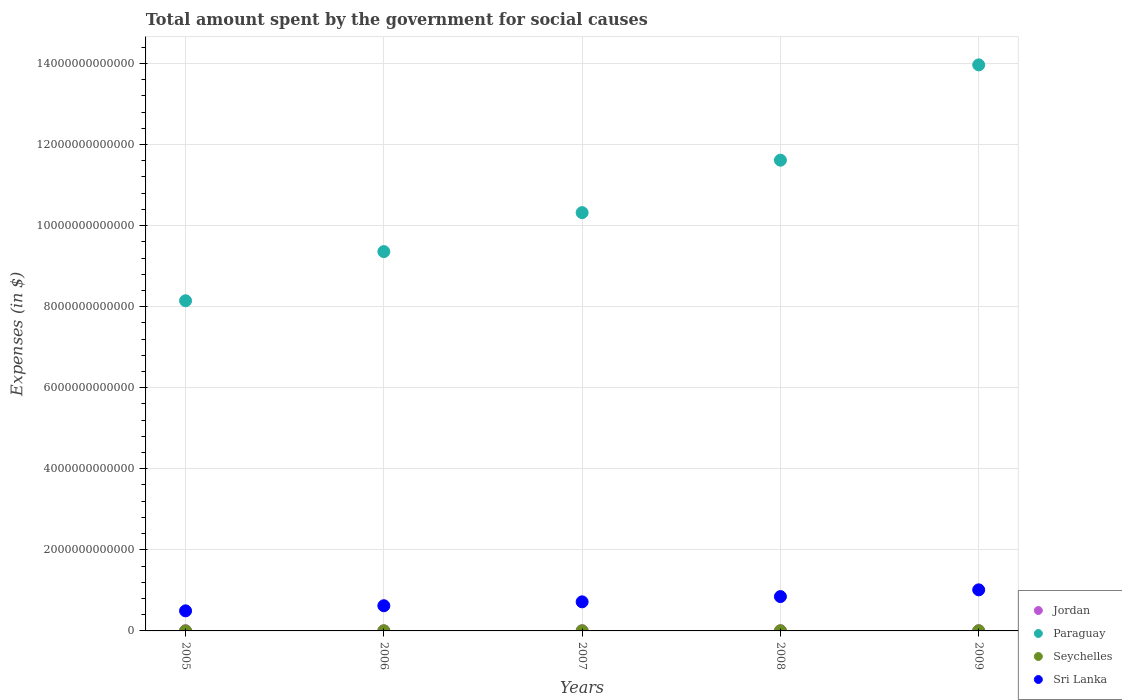Is the number of dotlines equal to the number of legend labels?
Provide a short and direct response. Yes. What is the amount spent for social causes by the government in Paraguay in 2006?
Offer a terse response. 9.36e+12. Across all years, what is the maximum amount spent for social causes by the government in Seychelles?
Your response must be concise. 3.40e+09. Across all years, what is the minimum amount spent for social causes by the government in Paraguay?
Make the answer very short. 8.15e+12. In which year was the amount spent for social causes by the government in Paraguay maximum?
Your response must be concise. 2009. In which year was the amount spent for social causes by the government in Jordan minimum?
Ensure brevity in your answer.  2005. What is the total amount spent for social causes by the government in Jordan in the graph?
Offer a very short reply. 2.08e+1. What is the difference between the amount spent for social causes by the government in Jordan in 2007 and that in 2008?
Offer a very short reply. -7.89e+08. What is the difference between the amount spent for social causes by the government in Seychelles in 2006 and the amount spent for social causes by the government in Sri Lanka in 2007?
Provide a short and direct response. -7.15e+11. What is the average amount spent for social causes by the government in Seychelles per year?
Make the answer very short. 2.52e+09. In the year 2006, what is the difference between the amount spent for social causes by the government in Paraguay and amount spent for social causes by the government in Sri Lanka?
Keep it short and to the point. 8.74e+12. What is the ratio of the amount spent for social causes by the government in Paraguay in 2006 to that in 2008?
Your answer should be compact. 0.81. Is the amount spent for social causes by the government in Jordan in 2006 less than that in 2009?
Your response must be concise. Yes. What is the difference between the highest and the second highest amount spent for social causes by the government in Sri Lanka?
Offer a terse response. 1.66e+11. What is the difference between the highest and the lowest amount spent for social causes by the government in Seychelles?
Offer a very short reply. 1.56e+09. In how many years, is the amount spent for social causes by the government in Seychelles greater than the average amount spent for social causes by the government in Seychelles taken over all years?
Give a very brief answer. 2. Is it the case that in every year, the sum of the amount spent for social causes by the government in Seychelles and amount spent for social causes by the government in Paraguay  is greater than the amount spent for social causes by the government in Sri Lanka?
Offer a very short reply. Yes. How many years are there in the graph?
Offer a terse response. 5. What is the difference between two consecutive major ticks on the Y-axis?
Your response must be concise. 2.00e+12. Are the values on the major ticks of Y-axis written in scientific E-notation?
Make the answer very short. No. Where does the legend appear in the graph?
Offer a very short reply. Bottom right. What is the title of the graph?
Keep it short and to the point. Total amount spent by the government for social causes. Does "Lesotho" appear as one of the legend labels in the graph?
Provide a short and direct response. No. What is the label or title of the X-axis?
Give a very brief answer. Years. What is the label or title of the Y-axis?
Your response must be concise. Expenses (in $). What is the Expenses (in $) of Jordan in 2005?
Provide a succinct answer. 3.18e+09. What is the Expenses (in $) of Paraguay in 2005?
Give a very brief answer. 8.15e+12. What is the Expenses (in $) in Seychelles in 2005?
Give a very brief answer. 1.83e+09. What is the Expenses (in $) of Sri Lanka in 2005?
Keep it short and to the point. 4.95e+11. What is the Expenses (in $) of Jordan in 2006?
Your answer should be very brief. 3.50e+09. What is the Expenses (in $) of Paraguay in 2006?
Your answer should be very brief. 9.36e+12. What is the Expenses (in $) in Seychelles in 2006?
Ensure brevity in your answer.  2.22e+09. What is the Expenses (in $) in Sri Lanka in 2006?
Offer a very short reply. 6.21e+11. What is the Expenses (in $) of Jordan in 2007?
Your answer should be compact. 4.11e+09. What is the Expenses (in $) of Paraguay in 2007?
Make the answer very short. 1.03e+13. What is the Expenses (in $) of Seychelles in 2007?
Provide a short and direct response. 2.52e+09. What is the Expenses (in $) in Sri Lanka in 2007?
Keep it short and to the point. 7.17e+11. What is the Expenses (in $) in Jordan in 2008?
Ensure brevity in your answer.  4.90e+09. What is the Expenses (in $) of Paraguay in 2008?
Your response must be concise. 1.16e+13. What is the Expenses (in $) of Seychelles in 2008?
Give a very brief answer. 2.63e+09. What is the Expenses (in $) in Sri Lanka in 2008?
Give a very brief answer. 8.47e+11. What is the Expenses (in $) of Jordan in 2009?
Keep it short and to the point. 5.09e+09. What is the Expenses (in $) in Paraguay in 2009?
Provide a short and direct response. 1.40e+13. What is the Expenses (in $) in Seychelles in 2009?
Your response must be concise. 3.40e+09. What is the Expenses (in $) in Sri Lanka in 2009?
Provide a short and direct response. 1.01e+12. Across all years, what is the maximum Expenses (in $) in Jordan?
Your response must be concise. 5.09e+09. Across all years, what is the maximum Expenses (in $) in Paraguay?
Keep it short and to the point. 1.40e+13. Across all years, what is the maximum Expenses (in $) of Seychelles?
Your answer should be very brief. 3.40e+09. Across all years, what is the maximum Expenses (in $) of Sri Lanka?
Keep it short and to the point. 1.01e+12. Across all years, what is the minimum Expenses (in $) in Jordan?
Make the answer very short. 3.18e+09. Across all years, what is the minimum Expenses (in $) in Paraguay?
Your response must be concise. 8.15e+12. Across all years, what is the minimum Expenses (in $) of Seychelles?
Your answer should be compact. 1.83e+09. Across all years, what is the minimum Expenses (in $) in Sri Lanka?
Ensure brevity in your answer.  4.95e+11. What is the total Expenses (in $) in Jordan in the graph?
Offer a terse response. 2.08e+1. What is the total Expenses (in $) in Paraguay in the graph?
Your answer should be very brief. 5.34e+13. What is the total Expenses (in $) of Seychelles in the graph?
Provide a short and direct response. 1.26e+1. What is the total Expenses (in $) of Sri Lanka in the graph?
Provide a short and direct response. 3.70e+12. What is the difference between the Expenses (in $) in Jordan in 2005 and that in 2006?
Make the answer very short. -3.15e+08. What is the difference between the Expenses (in $) in Paraguay in 2005 and that in 2006?
Offer a very short reply. -1.21e+12. What is the difference between the Expenses (in $) of Seychelles in 2005 and that in 2006?
Provide a succinct answer. -3.91e+08. What is the difference between the Expenses (in $) of Sri Lanka in 2005 and that in 2006?
Give a very brief answer. -1.26e+11. What is the difference between the Expenses (in $) of Jordan in 2005 and that in 2007?
Make the answer very short. -9.29e+08. What is the difference between the Expenses (in $) in Paraguay in 2005 and that in 2007?
Offer a very short reply. -2.17e+12. What is the difference between the Expenses (in $) of Seychelles in 2005 and that in 2007?
Your answer should be very brief. -6.84e+08. What is the difference between the Expenses (in $) of Sri Lanka in 2005 and that in 2007?
Your answer should be compact. -2.22e+11. What is the difference between the Expenses (in $) of Jordan in 2005 and that in 2008?
Your response must be concise. -1.72e+09. What is the difference between the Expenses (in $) of Paraguay in 2005 and that in 2008?
Your answer should be compact. -3.47e+12. What is the difference between the Expenses (in $) of Seychelles in 2005 and that in 2008?
Your answer should be very brief. -7.92e+08. What is the difference between the Expenses (in $) of Sri Lanka in 2005 and that in 2008?
Offer a terse response. -3.52e+11. What is the difference between the Expenses (in $) in Jordan in 2005 and that in 2009?
Offer a very short reply. -1.91e+09. What is the difference between the Expenses (in $) of Paraguay in 2005 and that in 2009?
Make the answer very short. -5.82e+12. What is the difference between the Expenses (in $) of Seychelles in 2005 and that in 2009?
Keep it short and to the point. -1.56e+09. What is the difference between the Expenses (in $) of Sri Lanka in 2005 and that in 2009?
Keep it short and to the point. -5.18e+11. What is the difference between the Expenses (in $) in Jordan in 2006 and that in 2007?
Provide a short and direct response. -6.14e+08. What is the difference between the Expenses (in $) in Paraguay in 2006 and that in 2007?
Provide a succinct answer. -9.61e+11. What is the difference between the Expenses (in $) of Seychelles in 2006 and that in 2007?
Keep it short and to the point. -2.94e+08. What is the difference between the Expenses (in $) of Sri Lanka in 2006 and that in 2007?
Offer a terse response. -9.59e+1. What is the difference between the Expenses (in $) of Jordan in 2006 and that in 2008?
Make the answer very short. -1.40e+09. What is the difference between the Expenses (in $) in Paraguay in 2006 and that in 2008?
Provide a succinct answer. -2.26e+12. What is the difference between the Expenses (in $) in Seychelles in 2006 and that in 2008?
Make the answer very short. -4.01e+08. What is the difference between the Expenses (in $) of Sri Lanka in 2006 and that in 2008?
Ensure brevity in your answer.  -2.26e+11. What is the difference between the Expenses (in $) in Jordan in 2006 and that in 2009?
Keep it short and to the point. -1.59e+09. What is the difference between the Expenses (in $) of Paraguay in 2006 and that in 2009?
Provide a short and direct response. -4.61e+12. What is the difference between the Expenses (in $) in Seychelles in 2006 and that in 2009?
Provide a short and direct response. -1.17e+09. What is the difference between the Expenses (in $) of Sri Lanka in 2006 and that in 2009?
Your response must be concise. -3.92e+11. What is the difference between the Expenses (in $) of Jordan in 2007 and that in 2008?
Provide a succinct answer. -7.89e+08. What is the difference between the Expenses (in $) of Paraguay in 2007 and that in 2008?
Ensure brevity in your answer.  -1.29e+12. What is the difference between the Expenses (in $) in Seychelles in 2007 and that in 2008?
Make the answer very short. -1.07e+08. What is the difference between the Expenses (in $) in Sri Lanka in 2007 and that in 2008?
Your answer should be very brief. -1.30e+11. What is the difference between the Expenses (in $) of Jordan in 2007 and that in 2009?
Your answer should be compact. -9.79e+08. What is the difference between the Expenses (in $) in Paraguay in 2007 and that in 2009?
Keep it short and to the point. -3.65e+12. What is the difference between the Expenses (in $) in Seychelles in 2007 and that in 2009?
Provide a succinct answer. -8.80e+08. What is the difference between the Expenses (in $) in Sri Lanka in 2007 and that in 2009?
Offer a terse response. -2.96e+11. What is the difference between the Expenses (in $) in Jordan in 2008 and that in 2009?
Provide a succinct answer. -1.90e+08. What is the difference between the Expenses (in $) of Paraguay in 2008 and that in 2009?
Offer a terse response. -2.35e+12. What is the difference between the Expenses (in $) of Seychelles in 2008 and that in 2009?
Give a very brief answer. -7.73e+08. What is the difference between the Expenses (in $) of Sri Lanka in 2008 and that in 2009?
Ensure brevity in your answer.  -1.66e+11. What is the difference between the Expenses (in $) in Jordan in 2005 and the Expenses (in $) in Paraguay in 2006?
Provide a succinct answer. -9.35e+12. What is the difference between the Expenses (in $) in Jordan in 2005 and the Expenses (in $) in Seychelles in 2006?
Make the answer very short. 9.58e+08. What is the difference between the Expenses (in $) of Jordan in 2005 and the Expenses (in $) of Sri Lanka in 2006?
Your answer should be compact. -6.18e+11. What is the difference between the Expenses (in $) of Paraguay in 2005 and the Expenses (in $) of Seychelles in 2006?
Provide a succinct answer. 8.14e+12. What is the difference between the Expenses (in $) in Paraguay in 2005 and the Expenses (in $) in Sri Lanka in 2006?
Keep it short and to the point. 7.52e+12. What is the difference between the Expenses (in $) in Seychelles in 2005 and the Expenses (in $) in Sri Lanka in 2006?
Provide a succinct answer. -6.20e+11. What is the difference between the Expenses (in $) of Jordan in 2005 and the Expenses (in $) of Paraguay in 2007?
Keep it short and to the point. -1.03e+13. What is the difference between the Expenses (in $) of Jordan in 2005 and the Expenses (in $) of Seychelles in 2007?
Offer a very short reply. 6.64e+08. What is the difference between the Expenses (in $) of Jordan in 2005 and the Expenses (in $) of Sri Lanka in 2007?
Give a very brief answer. -7.14e+11. What is the difference between the Expenses (in $) of Paraguay in 2005 and the Expenses (in $) of Seychelles in 2007?
Provide a succinct answer. 8.14e+12. What is the difference between the Expenses (in $) in Paraguay in 2005 and the Expenses (in $) in Sri Lanka in 2007?
Offer a very short reply. 7.43e+12. What is the difference between the Expenses (in $) of Seychelles in 2005 and the Expenses (in $) of Sri Lanka in 2007?
Provide a succinct answer. -7.16e+11. What is the difference between the Expenses (in $) in Jordan in 2005 and the Expenses (in $) in Paraguay in 2008?
Give a very brief answer. -1.16e+13. What is the difference between the Expenses (in $) in Jordan in 2005 and the Expenses (in $) in Seychelles in 2008?
Offer a very short reply. 5.57e+08. What is the difference between the Expenses (in $) of Jordan in 2005 and the Expenses (in $) of Sri Lanka in 2008?
Your answer should be compact. -8.44e+11. What is the difference between the Expenses (in $) of Paraguay in 2005 and the Expenses (in $) of Seychelles in 2008?
Ensure brevity in your answer.  8.14e+12. What is the difference between the Expenses (in $) in Paraguay in 2005 and the Expenses (in $) in Sri Lanka in 2008?
Your answer should be very brief. 7.30e+12. What is the difference between the Expenses (in $) of Seychelles in 2005 and the Expenses (in $) of Sri Lanka in 2008?
Offer a terse response. -8.46e+11. What is the difference between the Expenses (in $) in Jordan in 2005 and the Expenses (in $) in Paraguay in 2009?
Provide a short and direct response. -1.40e+13. What is the difference between the Expenses (in $) in Jordan in 2005 and the Expenses (in $) in Seychelles in 2009?
Make the answer very short. -2.16e+08. What is the difference between the Expenses (in $) of Jordan in 2005 and the Expenses (in $) of Sri Lanka in 2009?
Offer a terse response. -1.01e+12. What is the difference between the Expenses (in $) of Paraguay in 2005 and the Expenses (in $) of Seychelles in 2009?
Your answer should be very brief. 8.14e+12. What is the difference between the Expenses (in $) of Paraguay in 2005 and the Expenses (in $) of Sri Lanka in 2009?
Your response must be concise. 7.13e+12. What is the difference between the Expenses (in $) in Seychelles in 2005 and the Expenses (in $) in Sri Lanka in 2009?
Give a very brief answer. -1.01e+12. What is the difference between the Expenses (in $) in Jordan in 2006 and the Expenses (in $) in Paraguay in 2007?
Your response must be concise. -1.03e+13. What is the difference between the Expenses (in $) of Jordan in 2006 and the Expenses (in $) of Seychelles in 2007?
Keep it short and to the point. 9.79e+08. What is the difference between the Expenses (in $) in Jordan in 2006 and the Expenses (in $) in Sri Lanka in 2007?
Your response must be concise. -7.14e+11. What is the difference between the Expenses (in $) of Paraguay in 2006 and the Expenses (in $) of Seychelles in 2007?
Provide a succinct answer. 9.36e+12. What is the difference between the Expenses (in $) of Paraguay in 2006 and the Expenses (in $) of Sri Lanka in 2007?
Make the answer very short. 8.64e+12. What is the difference between the Expenses (in $) in Seychelles in 2006 and the Expenses (in $) in Sri Lanka in 2007?
Your answer should be compact. -7.15e+11. What is the difference between the Expenses (in $) of Jordan in 2006 and the Expenses (in $) of Paraguay in 2008?
Your response must be concise. -1.16e+13. What is the difference between the Expenses (in $) in Jordan in 2006 and the Expenses (in $) in Seychelles in 2008?
Provide a succinct answer. 8.71e+08. What is the difference between the Expenses (in $) in Jordan in 2006 and the Expenses (in $) in Sri Lanka in 2008?
Provide a succinct answer. -8.44e+11. What is the difference between the Expenses (in $) in Paraguay in 2006 and the Expenses (in $) in Seychelles in 2008?
Make the answer very short. 9.36e+12. What is the difference between the Expenses (in $) in Paraguay in 2006 and the Expenses (in $) in Sri Lanka in 2008?
Give a very brief answer. 8.51e+12. What is the difference between the Expenses (in $) of Seychelles in 2006 and the Expenses (in $) of Sri Lanka in 2008?
Keep it short and to the point. -8.45e+11. What is the difference between the Expenses (in $) of Jordan in 2006 and the Expenses (in $) of Paraguay in 2009?
Your answer should be very brief. -1.40e+13. What is the difference between the Expenses (in $) of Jordan in 2006 and the Expenses (in $) of Seychelles in 2009?
Give a very brief answer. 9.83e+07. What is the difference between the Expenses (in $) in Jordan in 2006 and the Expenses (in $) in Sri Lanka in 2009?
Your answer should be very brief. -1.01e+12. What is the difference between the Expenses (in $) in Paraguay in 2006 and the Expenses (in $) in Seychelles in 2009?
Provide a short and direct response. 9.35e+12. What is the difference between the Expenses (in $) of Paraguay in 2006 and the Expenses (in $) of Sri Lanka in 2009?
Ensure brevity in your answer.  8.34e+12. What is the difference between the Expenses (in $) in Seychelles in 2006 and the Expenses (in $) in Sri Lanka in 2009?
Your answer should be very brief. -1.01e+12. What is the difference between the Expenses (in $) in Jordan in 2007 and the Expenses (in $) in Paraguay in 2008?
Offer a very short reply. -1.16e+13. What is the difference between the Expenses (in $) of Jordan in 2007 and the Expenses (in $) of Seychelles in 2008?
Give a very brief answer. 1.49e+09. What is the difference between the Expenses (in $) in Jordan in 2007 and the Expenses (in $) in Sri Lanka in 2008?
Your answer should be compact. -8.43e+11. What is the difference between the Expenses (in $) in Paraguay in 2007 and the Expenses (in $) in Seychelles in 2008?
Provide a succinct answer. 1.03e+13. What is the difference between the Expenses (in $) in Paraguay in 2007 and the Expenses (in $) in Sri Lanka in 2008?
Your response must be concise. 9.47e+12. What is the difference between the Expenses (in $) in Seychelles in 2007 and the Expenses (in $) in Sri Lanka in 2008?
Provide a short and direct response. -8.45e+11. What is the difference between the Expenses (in $) in Jordan in 2007 and the Expenses (in $) in Paraguay in 2009?
Your answer should be very brief. -1.40e+13. What is the difference between the Expenses (in $) of Jordan in 2007 and the Expenses (in $) of Seychelles in 2009?
Your answer should be very brief. 7.12e+08. What is the difference between the Expenses (in $) in Jordan in 2007 and the Expenses (in $) in Sri Lanka in 2009?
Provide a succinct answer. -1.01e+12. What is the difference between the Expenses (in $) of Paraguay in 2007 and the Expenses (in $) of Seychelles in 2009?
Provide a short and direct response. 1.03e+13. What is the difference between the Expenses (in $) of Paraguay in 2007 and the Expenses (in $) of Sri Lanka in 2009?
Give a very brief answer. 9.31e+12. What is the difference between the Expenses (in $) of Seychelles in 2007 and the Expenses (in $) of Sri Lanka in 2009?
Your answer should be compact. -1.01e+12. What is the difference between the Expenses (in $) in Jordan in 2008 and the Expenses (in $) in Paraguay in 2009?
Offer a very short reply. -1.40e+13. What is the difference between the Expenses (in $) in Jordan in 2008 and the Expenses (in $) in Seychelles in 2009?
Offer a very short reply. 1.50e+09. What is the difference between the Expenses (in $) of Jordan in 2008 and the Expenses (in $) of Sri Lanka in 2009?
Your answer should be compact. -1.01e+12. What is the difference between the Expenses (in $) in Paraguay in 2008 and the Expenses (in $) in Seychelles in 2009?
Provide a short and direct response. 1.16e+13. What is the difference between the Expenses (in $) in Paraguay in 2008 and the Expenses (in $) in Sri Lanka in 2009?
Provide a short and direct response. 1.06e+13. What is the difference between the Expenses (in $) of Seychelles in 2008 and the Expenses (in $) of Sri Lanka in 2009?
Provide a succinct answer. -1.01e+12. What is the average Expenses (in $) of Jordan per year?
Your answer should be very brief. 4.16e+09. What is the average Expenses (in $) in Paraguay per year?
Provide a short and direct response. 1.07e+13. What is the average Expenses (in $) in Seychelles per year?
Make the answer very short. 2.52e+09. What is the average Expenses (in $) in Sri Lanka per year?
Your response must be concise. 7.39e+11. In the year 2005, what is the difference between the Expenses (in $) in Jordan and Expenses (in $) in Paraguay?
Offer a terse response. -8.14e+12. In the year 2005, what is the difference between the Expenses (in $) in Jordan and Expenses (in $) in Seychelles?
Give a very brief answer. 1.35e+09. In the year 2005, what is the difference between the Expenses (in $) of Jordan and Expenses (in $) of Sri Lanka?
Your answer should be compact. -4.92e+11. In the year 2005, what is the difference between the Expenses (in $) of Paraguay and Expenses (in $) of Seychelles?
Your answer should be very brief. 8.14e+12. In the year 2005, what is the difference between the Expenses (in $) in Paraguay and Expenses (in $) in Sri Lanka?
Your answer should be very brief. 7.65e+12. In the year 2005, what is the difference between the Expenses (in $) in Seychelles and Expenses (in $) in Sri Lanka?
Your answer should be very brief. -4.94e+11. In the year 2006, what is the difference between the Expenses (in $) of Jordan and Expenses (in $) of Paraguay?
Offer a very short reply. -9.35e+12. In the year 2006, what is the difference between the Expenses (in $) in Jordan and Expenses (in $) in Seychelles?
Give a very brief answer. 1.27e+09. In the year 2006, what is the difference between the Expenses (in $) of Jordan and Expenses (in $) of Sri Lanka?
Make the answer very short. -6.18e+11. In the year 2006, what is the difference between the Expenses (in $) of Paraguay and Expenses (in $) of Seychelles?
Your answer should be compact. 9.36e+12. In the year 2006, what is the difference between the Expenses (in $) in Paraguay and Expenses (in $) in Sri Lanka?
Ensure brevity in your answer.  8.74e+12. In the year 2006, what is the difference between the Expenses (in $) in Seychelles and Expenses (in $) in Sri Lanka?
Your answer should be very brief. -6.19e+11. In the year 2007, what is the difference between the Expenses (in $) of Jordan and Expenses (in $) of Paraguay?
Provide a short and direct response. -1.03e+13. In the year 2007, what is the difference between the Expenses (in $) of Jordan and Expenses (in $) of Seychelles?
Provide a succinct answer. 1.59e+09. In the year 2007, what is the difference between the Expenses (in $) in Jordan and Expenses (in $) in Sri Lanka?
Provide a short and direct response. -7.13e+11. In the year 2007, what is the difference between the Expenses (in $) in Paraguay and Expenses (in $) in Seychelles?
Provide a succinct answer. 1.03e+13. In the year 2007, what is the difference between the Expenses (in $) of Paraguay and Expenses (in $) of Sri Lanka?
Offer a very short reply. 9.60e+12. In the year 2007, what is the difference between the Expenses (in $) of Seychelles and Expenses (in $) of Sri Lanka?
Your response must be concise. -7.15e+11. In the year 2008, what is the difference between the Expenses (in $) of Jordan and Expenses (in $) of Paraguay?
Your answer should be very brief. -1.16e+13. In the year 2008, what is the difference between the Expenses (in $) in Jordan and Expenses (in $) in Seychelles?
Offer a terse response. 2.27e+09. In the year 2008, what is the difference between the Expenses (in $) in Jordan and Expenses (in $) in Sri Lanka?
Offer a terse response. -8.42e+11. In the year 2008, what is the difference between the Expenses (in $) of Paraguay and Expenses (in $) of Seychelles?
Ensure brevity in your answer.  1.16e+13. In the year 2008, what is the difference between the Expenses (in $) in Paraguay and Expenses (in $) in Sri Lanka?
Provide a short and direct response. 1.08e+13. In the year 2008, what is the difference between the Expenses (in $) of Seychelles and Expenses (in $) of Sri Lanka?
Offer a very short reply. -8.45e+11. In the year 2009, what is the difference between the Expenses (in $) in Jordan and Expenses (in $) in Paraguay?
Your answer should be very brief. -1.40e+13. In the year 2009, what is the difference between the Expenses (in $) of Jordan and Expenses (in $) of Seychelles?
Provide a succinct answer. 1.69e+09. In the year 2009, what is the difference between the Expenses (in $) of Jordan and Expenses (in $) of Sri Lanka?
Provide a short and direct response. -1.01e+12. In the year 2009, what is the difference between the Expenses (in $) in Paraguay and Expenses (in $) in Seychelles?
Your response must be concise. 1.40e+13. In the year 2009, what is the difference between the Expenses (in $) in Paraguay and Expenses (in $) in Sri Lanka?
Your answer should be very brief. 1.30e+13. In the year 2009, what is the difference between the Expenses (in $) in Seychelles and Expenses (in $) in Sri Lanka?
Keep it short and to the point. -1.01e+12. What is the ratio of the Expenses (in $) of Jordan in 2005 to that in 2006?
Your answer should be compact. 0.91. What is the ratio of the Expenses (in $) of Paraguay in 2005 to that in 2006?
Make the answer very short. 0.87. What is the ratio of the Expenses (in $) in Seychelles in 2005 to that in 2006?
Offer a very short reply. 0.82. What is the ratio of the Expenses (in $) of Sri Lanka in 2005 to that in 2006?
Keep it short and to the point. 0.8. What is the ratio of the Expenses (in $) in Jordan in 2005 to that in 2007?
Your response must be concise. 0.77. What is the ratio of the Expenses (in $) in Paraguay in 2005 to that in 2007?
Give a very brief answer. 0.79. What is the ratio of the Expenses (in $) of Seychelles in 2005 to that in 2007?
Offer a very short reply. 0.73. What is the ratio of the Expenses (in $) of Sri Lanka in 2005 to that in 2007?
Provide a succinct answer. 0.69. What is the ratio of the Expenses (in $) of Jordan in 2005 to that in 2008?
Provide a short and direct response. 0.65. What is the ratio of the Expenses (in $) of Paraguay in 2005 to that in 2008?
Provide a short and direct response. 0.7. What is the ratio of the Expenses (in $) of Seychelles in 2005 to that in 2008?
Offer a terse response. 0.7. What is the ratio of the Expenses (in $) of Sri Lanka in 2005 to that in 2008?
Ensure brevity in your answer.  0.58. What is the ratio of the Expenses (in $) in Jordan in 2005 to that in 2009?
Your response must be concise. 0.63. What is the ratio of the Expenses (in $) of Paraguay in 2005 to that in 2009?
Your answer should be compact. 0.58. What is the ratio of the Expenses (in $) of Seychelles in 2005 to that in 2009?
Offer a very short reply. 0.54. What is the ratio of the Expenses (in $) in Sri Lanka in 2005 to that in 2009?
Make the answer very short. 0.49. What is the ratio of the Expenses (in $) of Jordan in 2006 to that in 2007?
Make the answer very short. 0.85. What is the ratio of the Expenses (in $) of Paraguay in 2006 to that in 2007?
Offer a terse response. 0.91. What is the ratio of the Expenses (in $) of Seychelles in 2006 to that in 2007?
Make the answer very short. 0.88. What is the ratio of the Expenses (in $) in Sri Lanka in 2006 to that in 2007?
Make the answer very short. 0.87. What is the ratio of the Expenses (in $) of Jordan in 2006 to that in 2008?
Ensure brevity in your answer.  0.71. What is the ratio of the Expenses (in $) of Paraguay in 2006 to that in 2008?
Keep it short and to the point. 0.81. What is the ratio of the Expenses (in $) in Seychelles in 2006 to that in 2008?
Provide a short and direct response. 0.85. What is the ratio of the Expenses (in $) in Sri Lanka in 2006 to that in 2008?
Provide a short and direct response. 0.73. What is the ratio of the Expenses (in $) in Jordan in 2006 to that in 2009?
Keep it short and to the point. 0.69. What is the ratio of the Expenses (in $) in Paraguay in 2006 to that in 2009?
Offer a very short reply. 0.67. What is the ratio of the Expenses (in $) in Seychelles in 2006 to that in 2009?
Your answer should be very brief. 0.65. What is the ratio of the Expenses (in $) of Sri Lanka in 2006 to that in 2009?
Keep it short and to the point. 0.61. What is the ratio of the Expenses (in $) in Jordan in 2007 to that in 2008?
Offer a terse response. 0.84. What is the ratio of the Expenses (in $) in Paraguay in 2007 to that in 2008?
Your answer should be compact. 0.89. What is the ratio of the Expenses (in $) of Seychelles in 2007 to that in 2008?
Provide a short and direct response. 0.96. What is the ratio of the Expenses (in $) in Sri Lanka in 2007 to that in 2008?
Make the answer very short. 0.85. What is the ratio of the Expenses (in $) in Jordan in 2007 to that in 2009?
Offer a terse response. 0.81. What is the ratio of the Expenses (in $) in Paraguay in 2007 to that in 2009?
Offer a terse response. 0.74. What is the ratio of the Expenses (in $) of Seychelles in 2007 to that in 2009?
Offer a terse response. 0.74. What is the ratio of the Expenses (in $) in Sri Lanka in 2007 to that in 2009?
Keep it short and to the point. 0.71. What is the ratio of the Expenses (in $) in Jordan in 2008 to that in 2009?
Give a very brief answer. 0.96. What is the ratio of the Expenses (in $) of Paraguay in 2008 to that in 2009?
Provide a short and direct response. 0.83. What is the ratio of the Expenses (in $) of Seychelles in 2008 to that in 2009?
Give a very brief answer. 0.77. What is the ratio of the Expenses (in $) of Sri Lanka in 2008 to that in 2009?
Ensure brevity in your answer.  0.84. What is the difference between the highest and the second highest Expenses (in $) in Jordan?
Provide a short and direct response. 1.90e+08. What is the difference between the highest and the second highest Expenses (in $) of Paraguay?
Make the answer very short. 2.35e+12. What is the difference between the highest and the second highest Expenses (in $) in Seychelles?
Your answer should be very brief. 7.73e+08. What is the difference between the highest and the second highest Expenses (in $) of Sri Lanka?
Provide a succinct answer. 1.66e+11. What is the difference between the highest and the lowest Expenses (in $) of Jordan?
Provide a short and direct response. 1.91e+09. What is the difference between the highest and the lowest Expenses (in $) in Paraguay?
Offer a very short reply. 5.82e+12. What is the difference between the highest and the lowest Expenses (in $) of Seychelles?
Provide a short and direct response. 1.56e+09. What is the difference between the highest and the lowest Expenses (in $) in Sri Lanka?
Your response must be concise. 5.18e+11. 